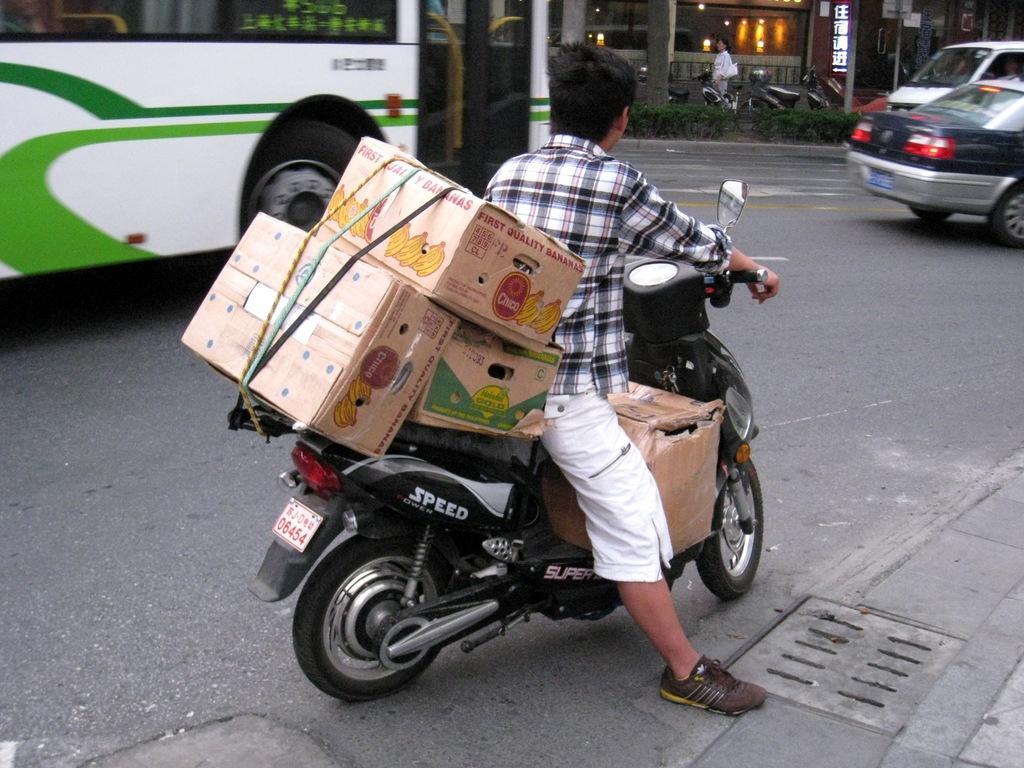How would you summarize this image in a sentence or two? In the center of the image there is a person sitting on the bike. There are carton boxes on the bike. In the background of the image there is a bus. There are cars. There are vehicles. There is a person. At the bottom of the image there is road. 